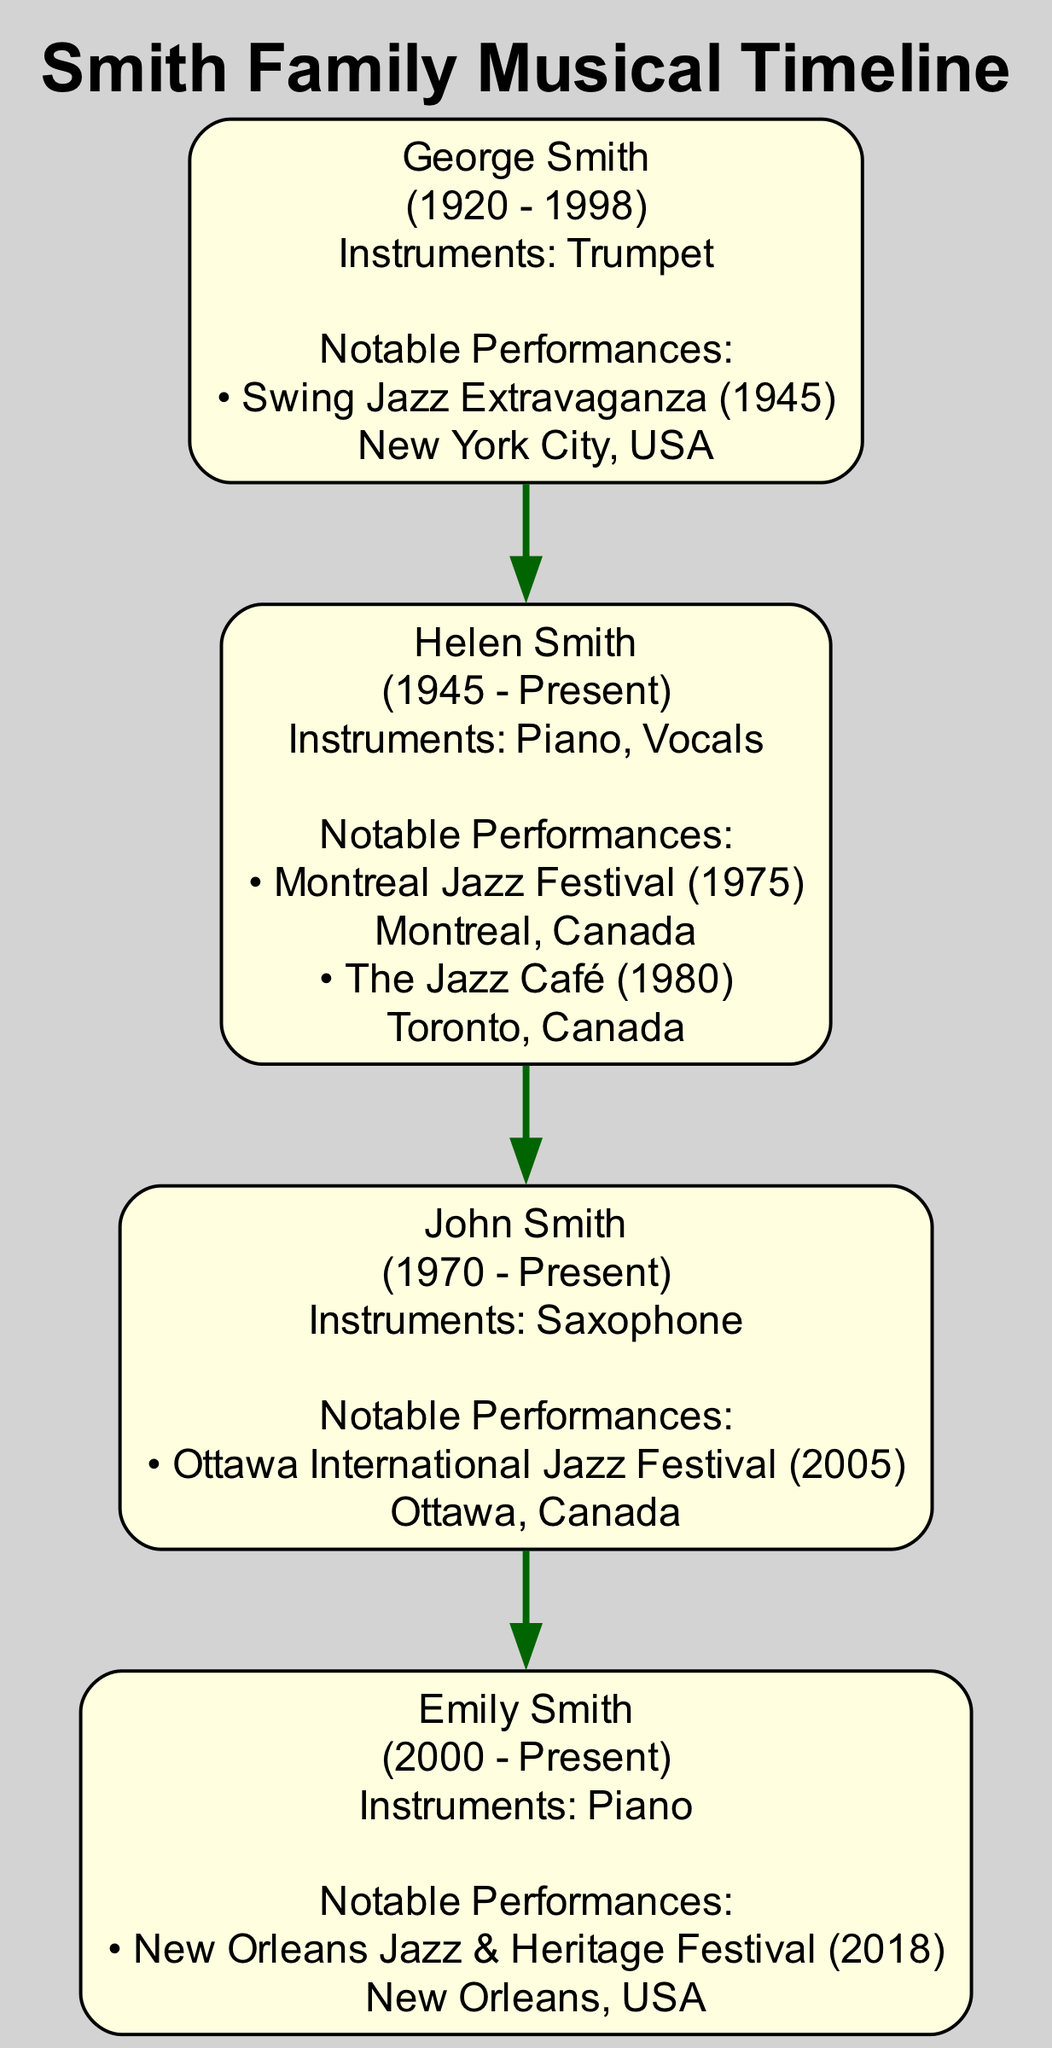What is the birth year of George Smith? The diagram indicates the birth year for George Smith, who is the first generation of the Smith family, is 1920. This information is directly presented in the node associated with him in the diagram.
Answer: 1920 How many instruments did Helen Smith play? By examining the node for Helen Smith in the diagram, we see that it lists her instruments as "Piano" and "Vocals." Counting these, we find that she played 2 instruments.
Answer: 2 What is the location of Emily Smith's notable performance? The description in Emily Smith's node states that her notable performance took place at the "New Orleans Jazz & Heritage Festival." This can be found in the details under her name in the diagram.
Answer: New Orleans, USA Which generation does John Smith belong to? By referencing the diagram, it shows that John Smith is labeled in the 3rd generation section. Each member is categorized according to their generation, making it clear that he is in the third.
Answer: 3rd Who had a notable performance in 1945? The diagram details that George Smith performed at the "Swing Jazz Extravaganza" in New York City in 1945. This event is listed under his performance details in the first generation.
Answer: George Smith What year did Emily Smith perform at her notable event? The diagram specifies that Emily Smith performed at the "New Orleans Jazz & Heritage Festival" in the year 2018. This information is included in her performance section in the diagram.
Answer: 2018 Which family member played the Saxophone? In examining the diagram, it is clear that John Smith is identified as the family member who plays the Saxophone, as specified in his node.
Answer: John Smith How many notable performances did Helen Smith have? Looking at the details under Helen Smith's node in the diagram, we see two notable performances listed: one at the Montreal Jazz Festival and another at The Jazz Café. Therefore, she had 2 performances.
Answer: 2 